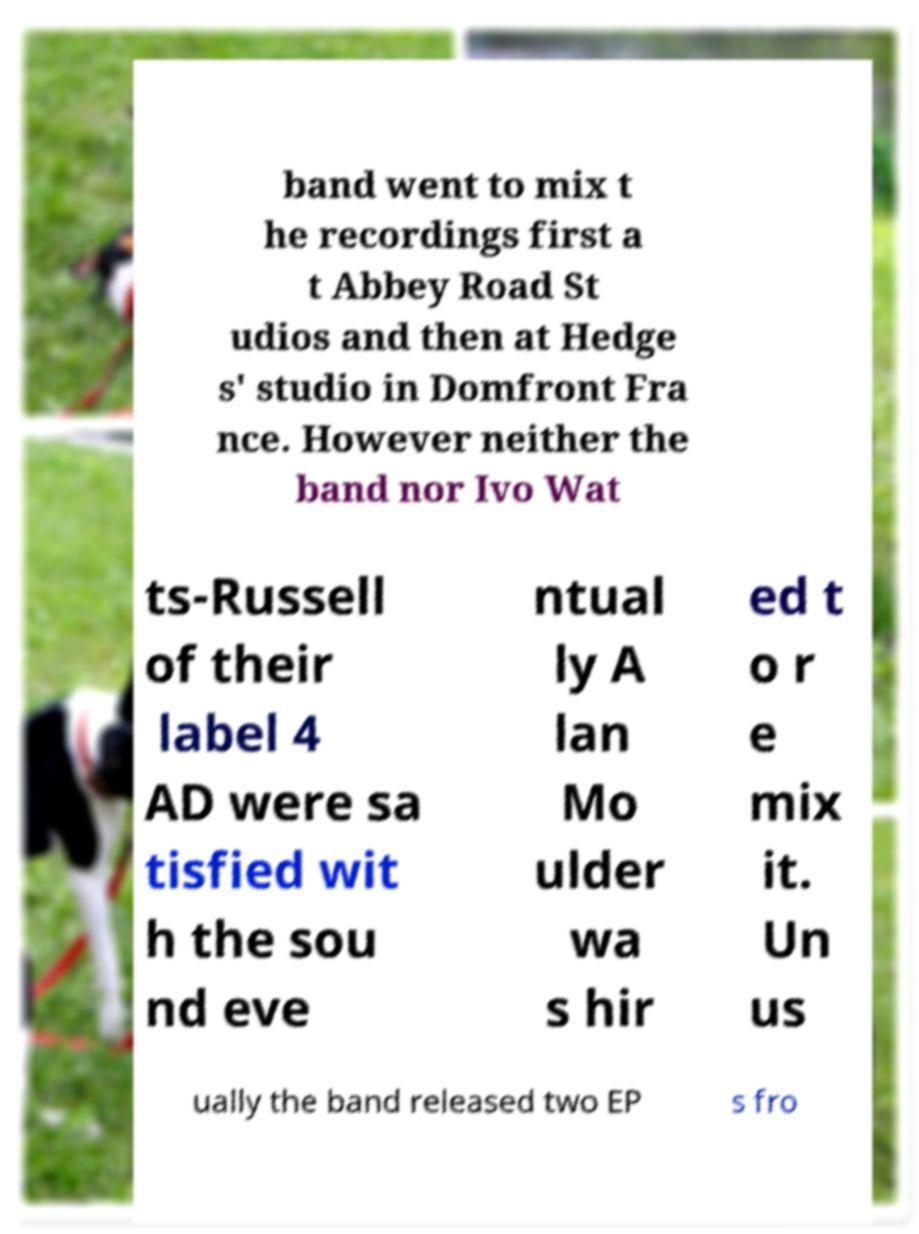What messages or text are displayed in this image? I need them in a readable, typed format. band went to mix t he recordings first a t Abbey Road St udios and then at Hedge s' studio in Domfront Fra nce. However neither the band nor Ivo Wat ts-Russell of their label 4 AD were sa tisfied wit h the sou nd eve ntual ly A lan Mo ulder wa s hir ed t o r e mix it. Un us ually the band released two EP s fro 